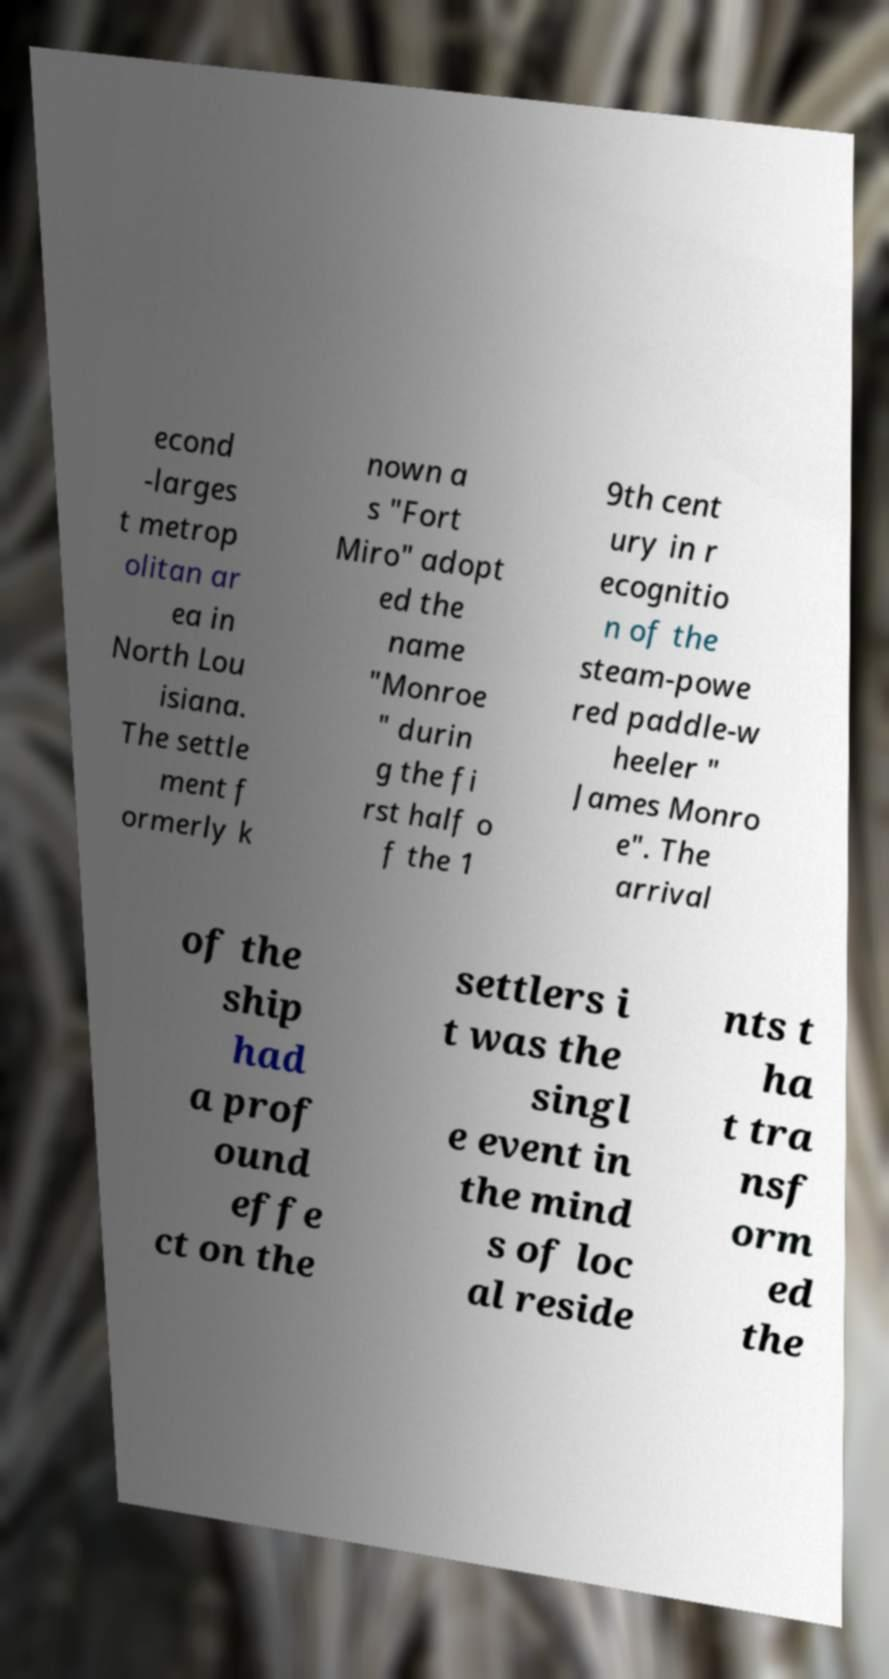Can you read and provide the text displayed in the image?This photo seems to have some interesting text. Can you extract and type it out for me? econd -larges t metrop olitan ar ea in North Lou isiana. The settle ment f ormerly k nown a s "Fort Miro" adopt ed the name "Monroe " durin g the fi rst half o f the 1 9th cent ury in r ecognitio n of the steam-powe red paddle-w heeler " James Monro e". The arrival of the ship had a prof ound effe ct on the settlers i t was the singl e event in the mind s of loc al reside nts t ha t tra nsf orm ed the 